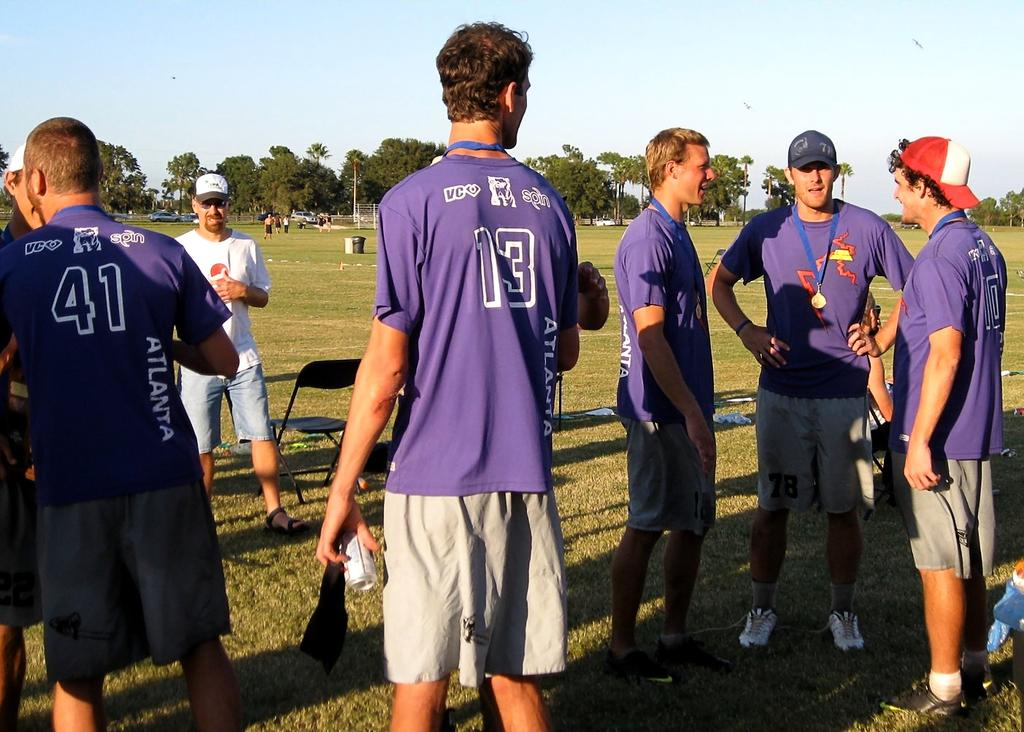<image>
Present a compact description of the photo's key features. players wearing purple vco spin atlanta shirts on a field talking 